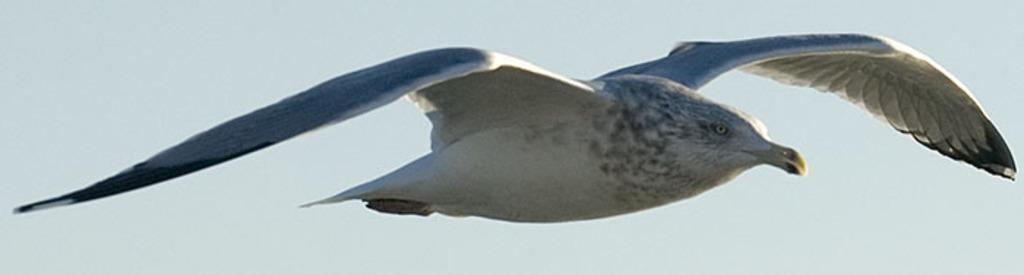Describe this image in one or two sentences. In this image there is a bird in the air. 